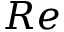<formula> <loc_0><loc_0><loc_500><loc_500>R e</formula> 